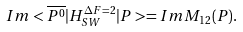Convert formula to latex. <formula><loc_0><loc_0><loc_500><loc_500>I m < \overline { P ^ { 0 } } | H _ { S W } ^ { { \Delta } F = 2 } | P > = I m M _ { 1 2 } ( P ) .</formula> 